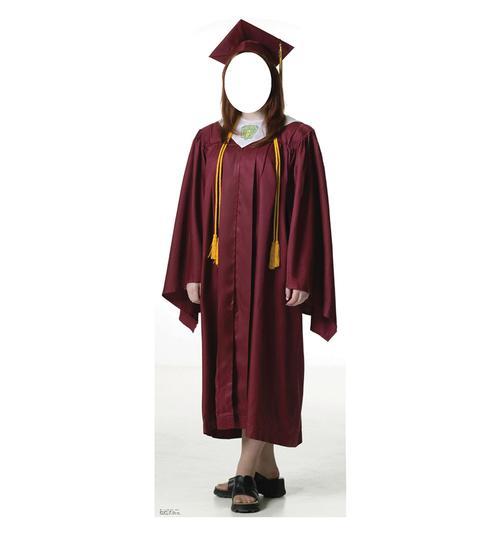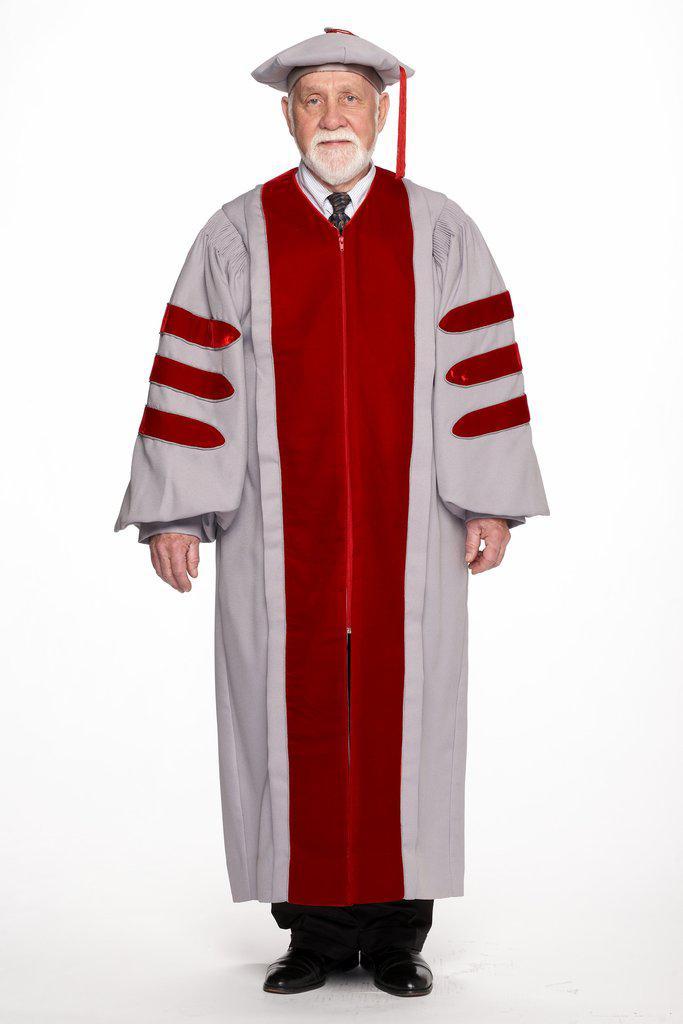The first image is the image on the left, the second image is the image on the right. Assess this claim about the two images: "There are two pink gowns with three horizontal black stripes on the sleeve.". Correct or not? Answer yes or no. No. The first image is the image on the left, the second image is the image on the right. Considering the images on both sides, is "One image shows a human male with facial hair modeling a tasseled cap and a robe with three stripes per sleeve." valid? Answer yes or no. Yes. 